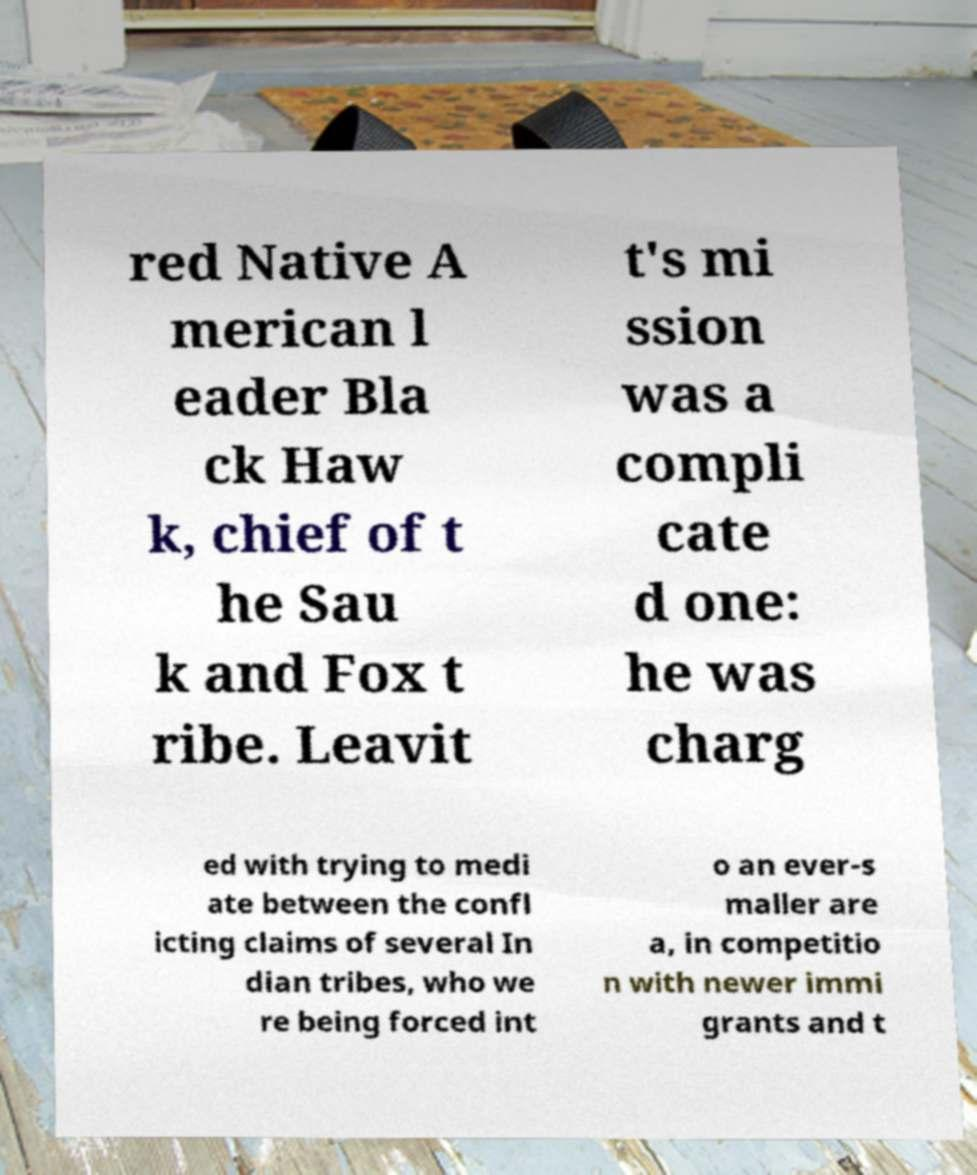I need the written content from this picture converted into text. Can you do that? red Native A merican l eader Bla ck Haw k, chief of t he Sau k and Fox t ribe. Leavit t's mi ssion was a compli cate d one: he was charg ed with trying to medi ate between the confl icting claims of several In dian tribes, who we re being forced int o an ever-s maller are a, in competitio n with newer immi grants and t 